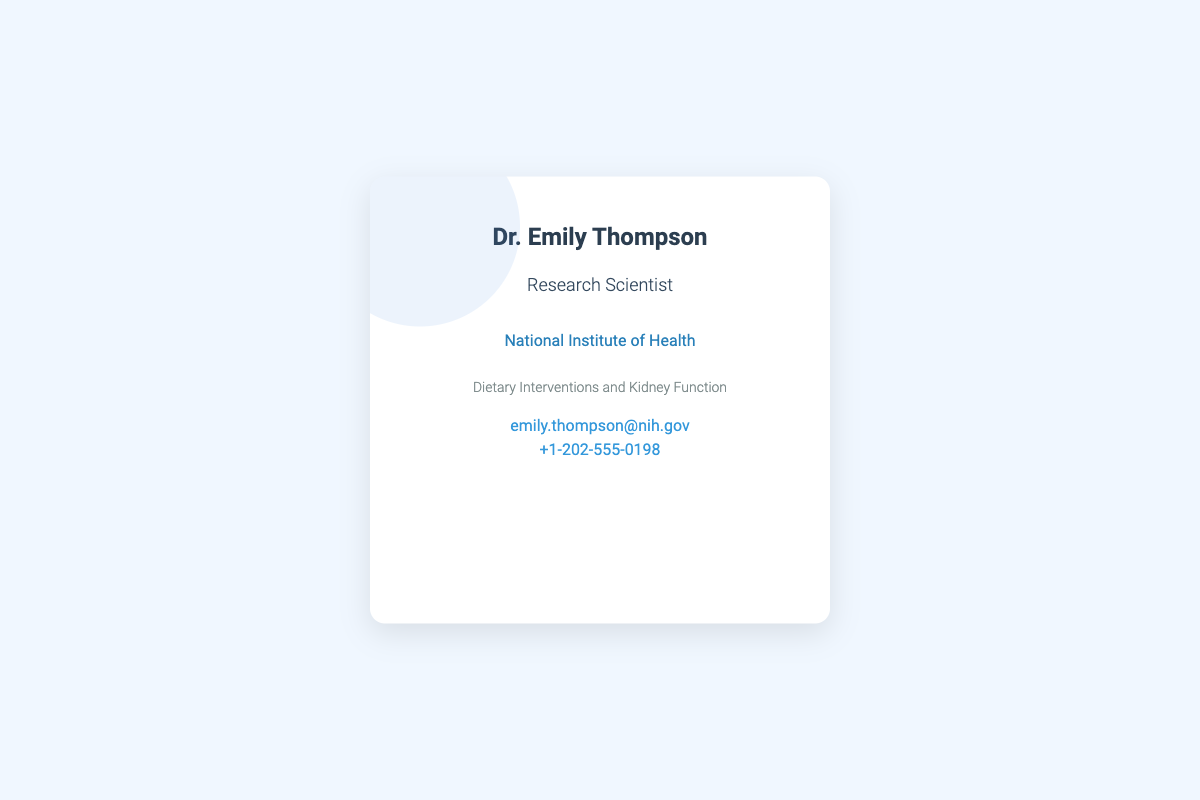What is the name of the researcher? The name of the researcher is clearly stated at the top of the document.
Answer: Dr. Emily Thompson What is the title of the individual? The title is displayed under the name, indicating the individual's professional role.
Answer: Research Scientist Which institution is the researcher affiliated with? The institution is mentioned in a separate line below the title.
Answer: National Institute of Health What is the specialization of the researcher? The specialization is described in a specific section of the document.
Answer: Dietary Interventions and Kidney Function What is the email address provided? The email address is listed under the contact information section of the document.
Answer: emily.thompson@nih.gov What is the phone number of the researcher? The phone number is shown alongside the email address in the contact section.
Answer: +1-202-555-0198 How many contact methods are provided? The contact information section lists two different types of contact methods.
Answer: Two What color theme is used for the business card? The background and card colors can give insight into the design theme used.
Answer: Blue and white What format does the document represent? The purpose of the document can be inferred from its structure and content.
Answer: Business card 